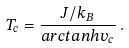Convert formula to latex. <formula><loc_0><loc_0><loc_500><loc_500>T _ { c } = \frac { J / k _ { B } } { a r c t a n h v _ { c } } \, .</formula> 